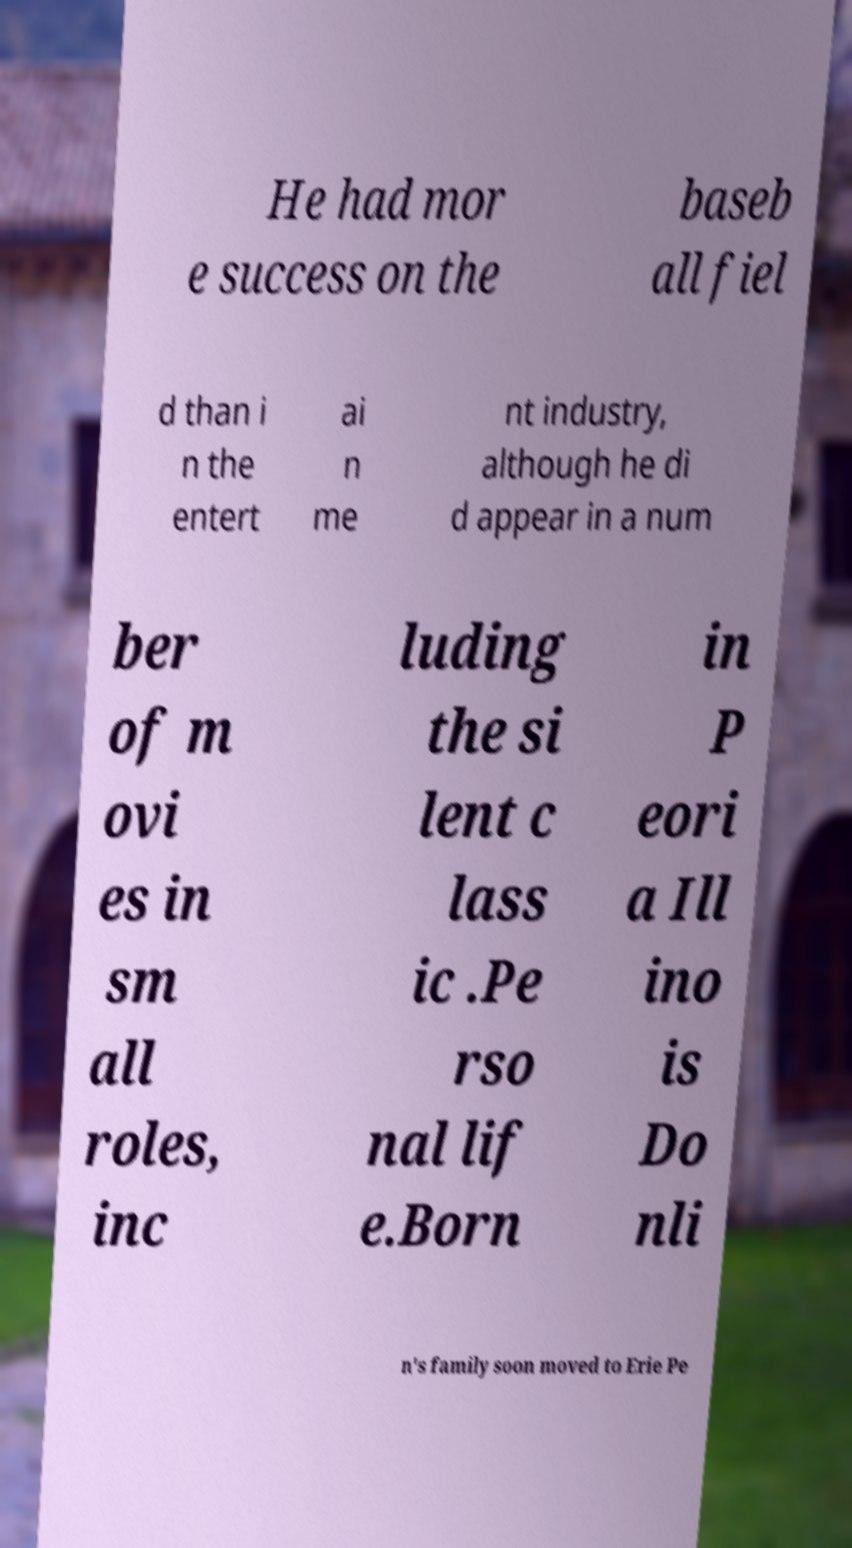What messages or text are displayed in this image? I need them in a readable, typed format. He had mor e success on the baseb all fiel d than i n the entert ai n me nt industry, although he di d appear in a num ber of m ovi es in sm all roles, inc luding the si lent c lass ic .Pe rso nal lif e.Born in P eori a Ill ino is Do nli n's family soon moved to Erie Pe 